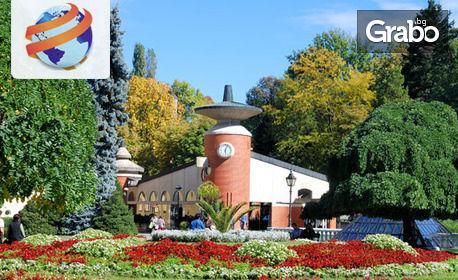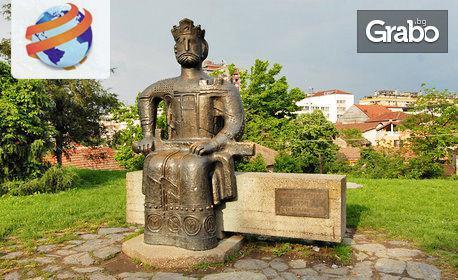The first image is the image on the left, the second image is the image on the right. For the images shown, is this caption "An ornate orange monastery has a rounded structure at one end with one central window with a curved top, and a small shed-like structure on at least one side." true? Answer yes or no. No. The first image is the image on the left, the second image is the image on the right. Evaluate the accuracy of this statement regarding the images: "Each image shows a red-orange building featuring a dome structure topped with a cross.". Is it true? Answer yes or no. No. 